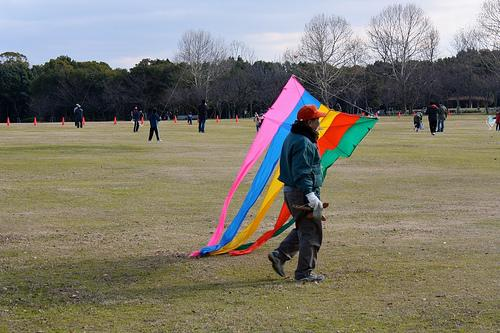Which color of the rainbow is missing from this kite?

Choices:
A) brown
B) blue
C) green
D) yellow yellow 